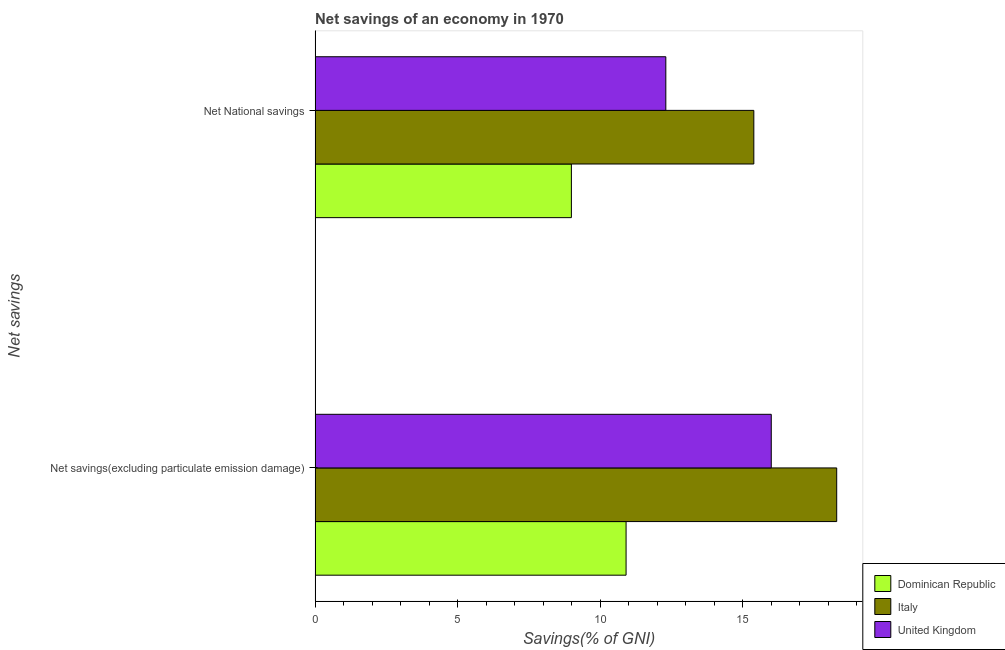How many groups of bars are there?
Provide a succinct answer. 2. Are the number of bars per tick equal to the number of legend labels?
Offer a terse response. Yes. Are the number of bars on each tick of the Y-axis equal?
Keep it short and to the point. Yes. How many bars are there on the 1st tick from the bottom?
Offer a terse response. 3. What is the label of the 2nd group of bars from the top?
Provide a succinct answer. Net savings(excluding particulate emission damage). What is the net national savings in United Kingdom?
Make the answer very short. 12.31. Across all countries, what is the maximum net savings(excluding particulate emission damage)?
Provide a succinct answer. 18.3. Across all countries, what is the minimum net savings(excluding particulate emission damage)?
Offer a very short reply. 10.91. In which country was the net national savings minimum?
Ensure brevity in your answer.  Dominican Republic. What is the total net national savings in the graph?
Your response must be concise. 36.7. What is the difference between the net savings(excluding particulate emission damage) in Italy and that in United Kingdom?
Your answer should be very brief. 2.3. What is the difference between the net savings(excluding particulate emission damage) in Dominican Republic and the net national savings in Italy?
Give a very brief answer. -4.48. What is the average net savings(excluding particulate emission damage) per country?
Your response must be concise. 15.07. What is the difference between the net savings(excluding particulate emission damage) and net national savings in Italy?
Your response must be concise. 2.91. In how many countries, is the net savings(excluding particulate emission damage) greater than 6 %?
Your answer should be very brief. 3. What is the ratio of the net national savings in United Kingdom to that in Dominican Republic?
Provide a succinct answer. 1.37. In how many countries, is the net national savings greater than the average net national savings taken over all countries?
Give a very brief answer. 2. What does the 2nd bar from the top in Net National savings represents?
Your response must be concise. Italy. How many bars are there?
Keep it short and to the point. 6. How many countries are there in the graph?
Offer a terse response. 3. What is the difference between two consecutive major ticks on the X-axis?
Your answer should be very brief. 5. Are the values on the major ticks of X-axis written in scientific E-notation?
Provide a succinct answer. No. Does the graph contain any zero values?
Your answer should be very brief. No. Does the graph contain grids?
Provide a succinct answer. No. Where does the legend appear in the graph?
Offer a terse response. Bottom right. What is the title of the graph?
Provide a succinct answer. Net savings of an economy in 1970. What is the label or title of the X-axis?
Offer a very short reply. Savings(% of GNI). What is the label or title of the Y-axis?
Provide a succinct answer. Net savings. What is the Savings(% of GNI) of Dominican Republic in Net savings(excluding particulate emission damage)?
Offer a very short reply. 10.91. What is the Savings(% of GNI) in Italy in Net savings(excluding particulate emission damage)?
Your response must be concise. 18.3. What is the Savings(% of GNI) of United Kingdom in Net savings(excluding particulate emission damage)?
Your answer should be very brief. 16.01. What is the Savings(% of GNI) of Dominican Republic in Net National savings?
Offer a terse response. 8.99. What is the Savings(% of GNI) of Italy in Net National savings?
Offer a very short reply. 15.4. What is the Savings(% of GNI) of United Kingdom in Net National savings?
Offer a terse response. 12.31. Across all Net savings, what is the maximum Savings(% of GNI) in Dominican Republic?
Offer a very short reply. 10.91. Across all Net savings, what is the maximum Savings(% of GNI) in Italy?
Your answer should be very brief. 18.3. Across all Net savings, what is the maximum Savings(% of GNI) in United Kingdom?
Make the answer very short. 16.01. Across all Net savings, what is the minimum Savings(% of GNI) of Dominican Republic?
Keep it short and to the point. 8.99. Across all Net savings, what is the minimum Savings(% of GNI) of Italy?
Make the answer very short. 15.4. Across all Net savings, what is the minimum Savings(% of GNI) of United Kingdom?
Offer a terse response. 12.31. What is the total Savings(% of GNI) in Dominican Republic in the graph?
Your answer should be very brief. 19.91. What is the total Savings(% of GNI) in Italy in the graph?
Keep it short and to the point. 33.7. What is the total Savings(% of GNI) of United Kingdom in the graph?
Your response must be concise. 28.32. What is the difference between the Savings(% of GNI) in Dominican Republic in Net savings(excluding particulate emission damage) and that in Net National savings?
Provide a short and direct response. 1.92. What is the difference between the Savings(% of GNI) of Italy in Net savings(excluding particulate emission damage) and that in Net National savings?
Your answer should be compact. 2.91. What is the difference between the Savings(% of GNI) of United Kingdom in Net savings(excluding particulate emission damage) and that in Net National savings?
Offer a very short reply. 3.7. What is the difference between the Savings(% of GNI) of Dominican Republic in Net savings(excluding particulate emission damage) and the Savings(% of GNI) of Italy in Net National savings?
Your response must be concise. -4.48. What is the difference between the Savings(% of GNI) in Dominican Republic in Net savings(excluding particulate emission damage) and the Savings(% of GNI) in United Kingdom in Net National savings?
Ensure brevity in your answer.  -1.39. What is the difference between the Savings(% of GNI) in Italy in Net savings(excluding particulate emission damage) and the Savings(% of GNI) in United Kingdom in Net National savings?
Provide a succinct answer. 6. What is the average Savings(% of GNI) in Dominican Republic per Net savings?
Keep it short and to the point. 9.95. What is the average Savings(% of GNI) in Italy per Net savings?
Your response must be concise. 16.85. What is the average Savings(% of GNI) of United Kingdom per Net savings?
Your response must be concise. 14.16. What is the difference between the Savings(% of GNI) of Dominican Republic and Savings(% of GNI) of Italy in Net savings(excluding particulate emission damage)?
Offer a terse response. -7.39. What is the difference between the Savings(% of GNI) in Dominican Republic and Savings(% of GNI) in United Kingdom in Net savings(excluding particulate emission damage)?
Offer a very short reply. -5.09. What is the difference between the Savings(% of GNI) of Italy and Savings(% of GNI) of United Kingdom in Net savings(excluding particulate emission damage)?
Ensure brevity in your answer.  2.3. What is the difference between the Savings(% of GNI) in Dominican Republic and Savings(% of GNI) in Italy in Net National savings?
Make the answer very short. -6.4. What is the difference between the Savings(% of GNI) in Dominican Republic and Savings(% of GNI) in United Kingdom in Net National savings?
Your answer should be compact. -3.31. What is the difference between the Savings(% of GNI) in Italy and Savings(% of GNI) in United Kingdom in Net National savings?
Give a very brief answer. 3.09. What is the ratio of the Savings(% of GNI) of Dominican Republic in Net savings(excluding particulate emission damage) to that in Net National savings?
Your response must be concise. 1.21. What is the ratio of the Savings(% of GNI) of Italy in Net savings(excluding particulate emission damage) to that in Net National savings?
Offer a terse response. 1.19. What is the ratio of the Savings(% of GNI) of United Kingdom in Net savings(excluding particulate emission damage) to that in Net National savings?
Provide a succinct answer. 1.3. What is the difference between the highest and the second highest Savings(% of GNI) in Dominican Republic?
Offer a terse response. 1.92. What is the difference between the highest and the second highest Savings(% of GNI) of Italy?
Your answer should be very brief. 2.91. What is the difference between the highest and the second highest Savings(% of GNI) of United Kingdom?
Your response must be concise. 3.7. What is the difference between the highest and the lowest Savings(% of GNI) in Dominican Republic?
Your answer should be compact. 1.92. What is the difference between the highest and the lowest Savings(% of GNI) of Italy?
Provide a short and direct response. 2.91. What is the difference between the highest and the lowest Savings(% of GNI) of United Kingdom?
Offer a terse response. 3.7. 